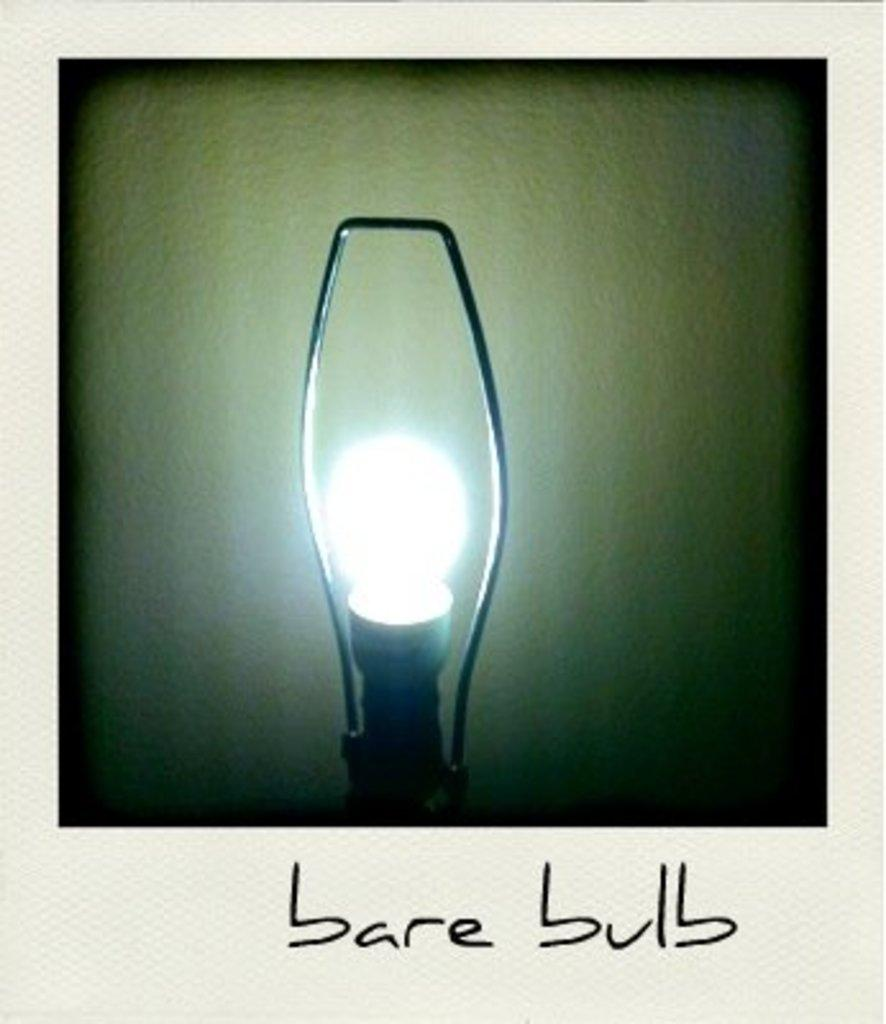What object is present in the image? There is a bulb in the image. Can you describe the bulb in the image? The bulb appears to be an electric light bulb. What might the bulb be used for in the image? The bulb might be used for providing light in the depicted setting. How many pages does the bulb have in the image? The bulb does not have pages, as it is an electric light bulb and not a book or document. 